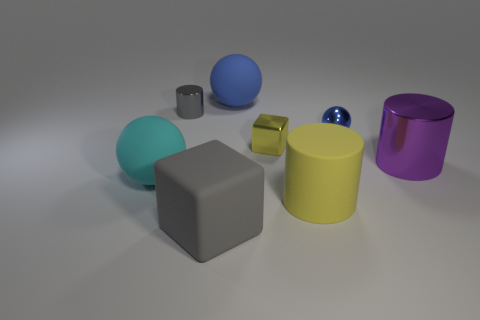How many other metallic cubes are the same color as the big cube? There are no other metallic cubes that share the same color as the large gray cube in the image. 